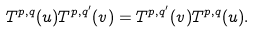<formula> <loc_0><loc_0><loc_500><loc_500>T ^ { p , q } ( u ) T ^ { p , q ^ { \prime } } ( v ) = T ^ { p , q ^ { \prime } } ( v ) T ^ { p , q } ( u ) .</formula> 